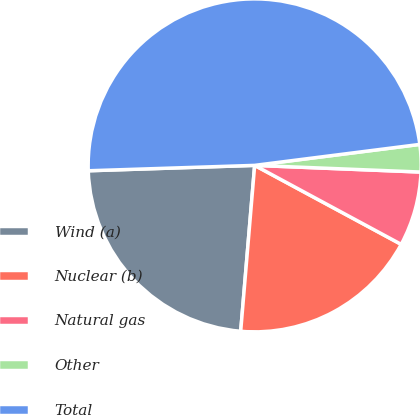<chart> <loc_0><loc_0><loc_500><loc_500><pie_chart><fcel>Wind (a)<fcel>Nuclear (b)<fcel>Natural gas<fcel>Other<fcel>Total<nl><fcel>23.15%<fcel>18.47%<fcel>7.23%<fcel>2.65%<fcel>48.51%<nl></chart> 